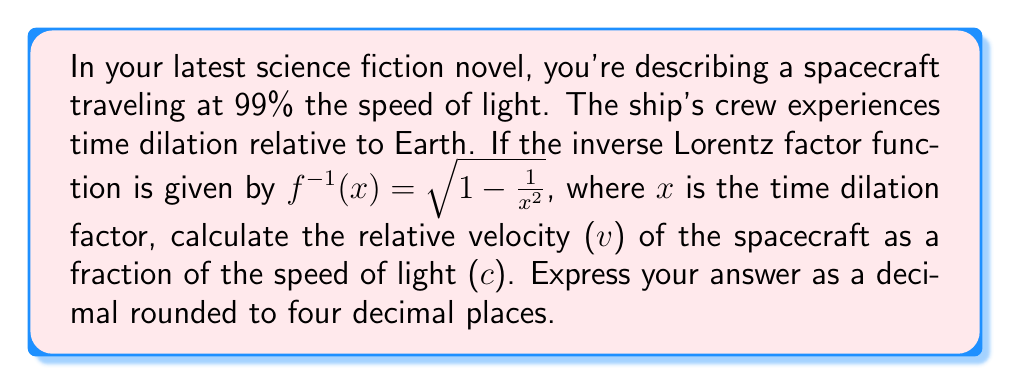Help me with this question. To solve this problem, we need to follow these steps:

1) First, recall that the time dilation factor ($\gamma$) is given by:

   $$\gamma = \frac{1}{\sqrt{1 - \frac{v^2}{c^2}}}$$

2) We're given that the ship is traveling at 99% the speed of light, so the time dilation factor is:

   $$\gamma = \frac{1}{\sqrt{1 - 0.99^2}} \approx 7.0888$$

3) Now, we're given the inverse Lorentz factor function:

   $$f^{-1}(x) = \sqrt{1 - \frac{1}{x^2}}$$

4) In this function, $x$ represents the time dilation factor ($\gamma$), and the output represents $\frac{v}{c}$.

5) Let's substitute our $\gamma$ value into this function:

   $$\frac{v}{c} = f^{-1}(7.0888) = \sqrt{1 - \frac{1}{7.0888^2}}$$

6) Calculating this:

   $$\frac{v}{c} = \sqrt{1 - \frac{1}{50.2500}} = \sqrt{1 - 0.0199} = \sqrt{0.9801} = 0.9900$$

7) Rounding to four decimal places:

   $$\frac{v}{c} \approx 0.9900$$

This confirms our initial assumption that the ship is traveling at 99% the speed of light.
Answer: 0.9900 